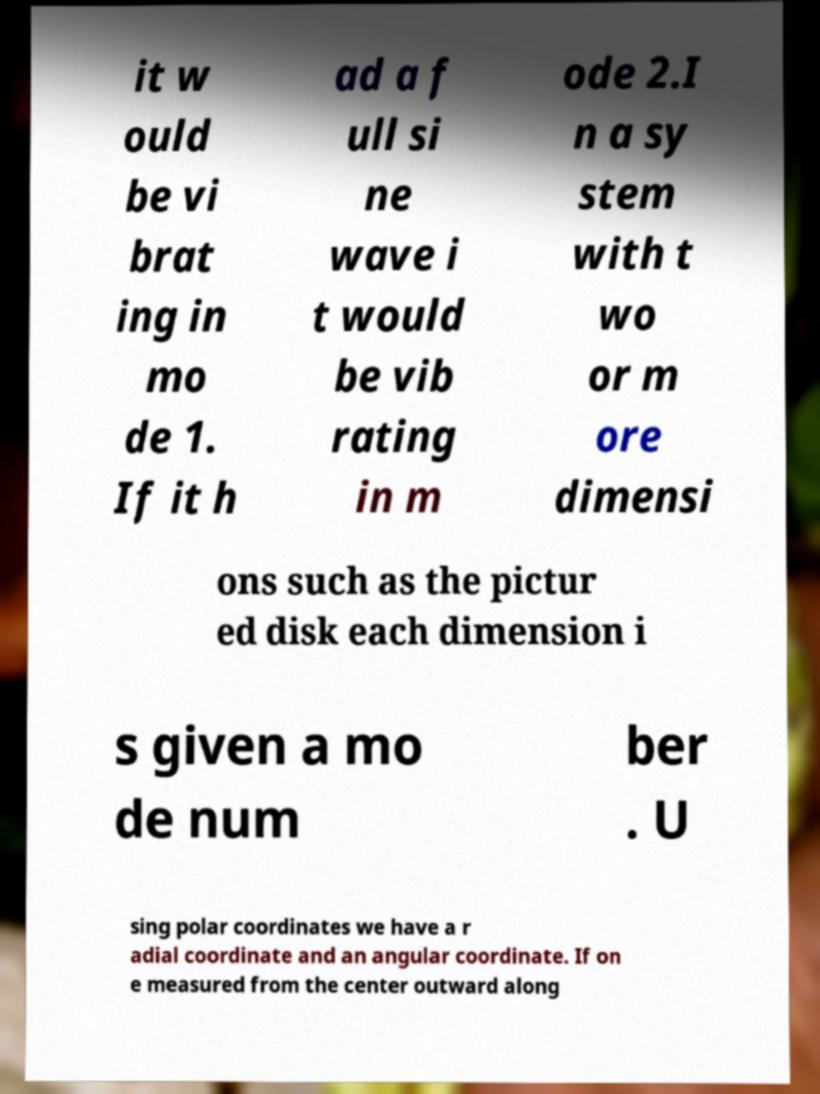There's text embedded in this image that I need extracted. Can you transcribe it verbatim? it w ould be vi brat ing in mo de 1. If it h ad a f ull si ne wave i t would be vib rating in m ode 2.I n a sy stem with t wo or m ore dimensi ons such as the pictur ed disk each dimension i s given a mo de num ber . U sing polar coordinates we have a r adial coordinate and an angular coordinate. If on e measured from the center outward along 